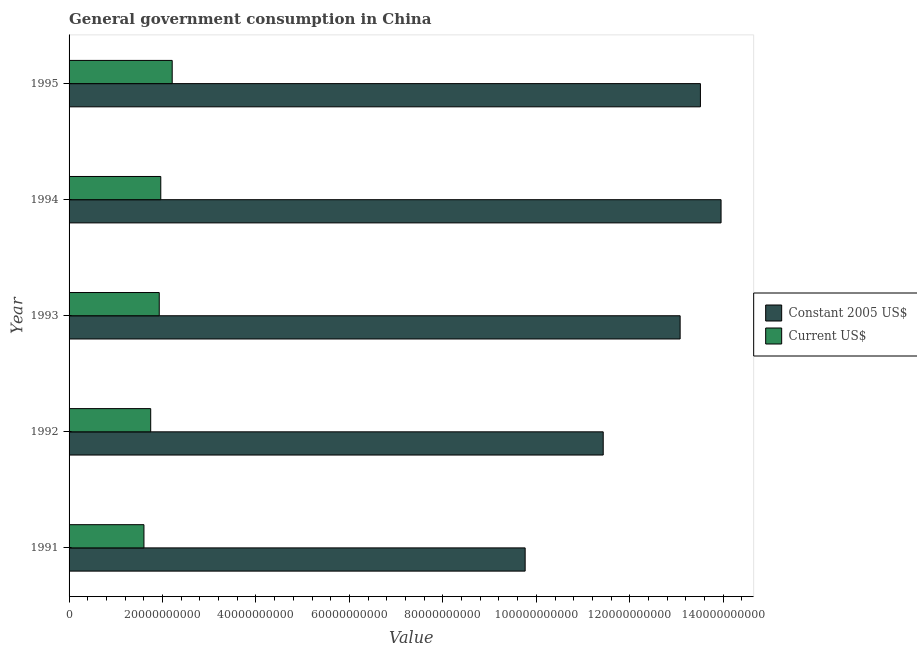How many different coloured bars are there?
Offer a terse response. 2. What is the label of the 3rd group of bars from the top?
Make the answer very short. 1993. What is the value consumed in constant 2005 us$ in 1993?
Your response must be concise. 1.31e+11. Across all years, what is the maximum value consumed in constant 2005 us$?
Ensure brevity in your answer.  1.40e+11. Across all years, what is the minimum value consumed in current us$?
Offer a terse response. 1.60e+1. What is the total value consumed in constant 2005 us$ in the graph?
Give a very brief answer. 6.17e+11. What is the difference between the value consumed in constant 2005 us$ in 1993 and that in 1994?
Offer a very short reply. -8.76e+09. What is the difference between the value consumed in current us$ in 1994 and the value consumed in constant 2005 us$ in 1993?
Offer a very short reply. -1.11e+11. What is the average value consumed in current us$ per year?
Provide a succinct answer. 1.89e+1. In the year 1992, what is the difference between the value consumed in current us$ and value consumed in constant 2005 us$?
Keep it short and to the point. -9.68e+1. In how many years, is the value consumed in constant 2005 us$ greater than 32000000000 ?
Provide a succinct answer. 5. What is the ratio of the value consumed in current us$ in 1994 to that in 1995?
Your response must be concise. 0.89. What is the difference between the highest and the second highest value consumed in constant 2005 us$?
Keep it short and to the point. 4.42e+09. What is the difference between the highest and the lowest value consumed in constant 2005 us$?
Give a very brief answer. 4.19e+1. What does the 2nd bar from the top in 1994 represents?
Make the answer very short. Constant 2005 US$. What does the 1st bar from the bottom in 1994 represents?
Ensure brevity in your answer.  Constant 2005 US$. Are all the bars in the graph horizontal?
Give a very brief answer. Yes. How many years are there in the graph?
Ensure brevity in your answer.  5. What is the difference between two consecutive major ticks on the X-axis?
Provide a succinct answer. 2.00e+1. Does the graph contain any zero values?
Offer a very short reply. No. Does the graph contain grids?
Your answer should be compact. No. Where does the legend appear in the graph?
Offer a very short reply. Center right. How many legend labels are there?
Make the answer very short. 2. What is the title of the graph?
Offer a terse response. General government consumption in China. Does "Non-resident workers" appear as one of the legend labels in the graph?
Keep it short and to the point. No. What is the label or title of the X-axis?
Give a very brief answer. Value. What is the Value of Constant 2005 US$ in 1991?
Your response must be concise. 9.76e+1. What is the Value of Current US$ in 1991?
Make the answer very short. 1.60e+1. What is the Value of Constant 2005 US$ in 1992?
Your answer should be compact. 1.14e+11. What is the Value of Current US$ in 1992?
Ensure brevity in your answer.  1.75e+1. What is the Value of Constant 2005 US$ in 1993?
Your response must be concise. 1.31e+11. What is the Value of Current US$ in 1993?
Provide a succinct answer. 1.93e+1. What is the Value of Constant 2005 US$ in 1994?
Your answer should be very brief. 1.40e+11. What is the Value in Current US$ in 1994?
Make the answer very short. 1.96e+1. What is the Value in Constant 2005 US$ in 1995?
Your response must be concise. 1.35e+11. What is the Value in Current US$ in 1995?
Ensure brevity in your answer.  2.21e+1. Across all years, what is the maximum Value in Constant 2005 US$?
Your answer should be compact. 1.40e+11. Across all years, what is the maximum Value in Current US$?
Your answer should be very brief. 2.21e+1. Across all years, what is the minimum Value of Constant 2005 US$?
Provide a succinct answer. 9.76e+1. Across all years, what is the minimum Value of Current US$?
Offer a very short reply. 1.60e+1. What is the total Value of Constant 2005 US$ in the graph?
Keep it short and to the point. 6.17e+11. What is the total Value of Current US$ in the graph?
Provide a short and direct response. 9.45e+1. What is the difference between the Value of Constant 2005 US$ in 1991 and that in 1992?
Keep it short and to the point. -1.67e+1. What is the difference between the Value in Current US$ in 1991 and that in 1992?
Give a very brief answer. -1.44e+09. What is the difference between the Value in Constant 2005 US$ in 1991 and that in 1993?
Your answer should be very brief. -3.32e+1. What is the difference between the Value in Current US$ in 1991 and that in 1993?
Your answer should be compact. -3.27e+09. What is the difference between the Value in Constant 2005 US$ in 1991 and that in 1994?
Your answer should be very brief. -4.19e+1. What is the difference between the Value in Current US$ in 1991 and that in 1994?
Make the answer very short. -3.60e+09. What is the difference between the Value of Constant 2005 US$ in 1991 and that in 1995?
Your response must be concise. -3.75e+1. What is the difference between the Value of Current US$ in 1991 and that in 1995?
Your answer should be compact. -6.04e+09. What is the difference between the Value of Constant 2005 US$ in 1992 and that in 1993?
Offer a very short reply. -1.65e+1. What is the difference between the Value of Current US$ in 1992 and that in 1993?
Provide a succinct answer. -1.83e+09. What is the difference between the Value in Constant 2005 US$ in 1992 and that in 1994?
Give a very brief answer. -2.52e+1. What is the difference between the Value in Current US$ in 1992 and that in 1994?
Provide a succinct answer. -2.16e+09. What is the difference between the Value of Constant 2005 US$ in 1992 and that in 1995?
Provide a short and direct response. -2.08e+1. What is the difference between the Value of Current US$ in 1992 and that in 1995?
Provide a succinct answer. -4.60e+09. What is the difference between the Value in Constant 2005 US$ in 1993 and that in 1994?
Provide a short and direct response. -8.76e+09. What is the difference between the Value in Current US$ in 1993 and that in 1994?
Offer a terse response. -3.27e+08. What is the difference between the Value in Constant 2005 US$ in 1993 and that in 1995?
Ensure brevity in your answer.  -4.34e+09. What is the difference between the Value in Current US$ in 1993 and that in 1995?
Provide a short and direct response. -2.77e+09. What is the difference between the Value of Constant 2005 US$ in 1994 and that in 1995?
Make the answer very short. 4.42e+09. What is the difference between the Value of Current US$ in 1994 and that in 1995?
Your response must be concise. -2.44e+09. What is the difference between the Value of Constant 2005 US$ in 1991 and the Value of Current US$ in 1992?
Offer a terse response. 8.01e+1. What is the difference between the Value in Constant 2005 US$ in 1991 and the Value in Current US$ in 1993?
Give a very brief answer. 7.83e+1. What is the difference between the Value in Constant 2005 US$ in 1991 and the Value in Current US$ in 1994?
Provide a succinct answer. 7.80e+1. What is the difference between the Value in Constant 2005 US$ in 1991 and the Value in Current US$ in 1995?
Keep it short and to the point. 7.55e+1. What is the difference between the Value of Constant 2005 US$ in 1992 and the Value of Current US$ in 1993?
Provide a short and direct response. 9.50e+1. What is the difference between the Value in Constant 2005 US$ in 1992 and the Value in Current US$ in 1994?
Your answer should be very brief. 9.47e+1. What is the difference between the Value of Constant 2005 US$ in 1992 and the Value of Current US$ in 1995?
Offer a very short reply. 9.22e+1. What is the difference between the Value in Constant 2005 US$ in 1993 and the Value in Current US$ in 1994?
Ensure brevity in your answer.  1.11e+11. What is the difference between the Value of Constant 2005 US$ in 1993 and the Value of Current US$ in 1995?
Make the answer very short. 1.09e+11. What is the difference between the Value of Constant 2005 US$ in 1994 and the Value of Current US$ in 1995?
Make the answer very short. 1.17e+11. What is the average Value of Constant 2005 US$ per year?
Provide a short and direct response. 1.23e+11. What is the average Value of Current US$ per year?
Ensure brevity in your answer.  1.89e+1. In the year 1991, what is the difference between the Value of Constant 2005 US$ and Value of Current US$?
Offer a terse response. 8.16e+1. In the year 1992, what is the difference between the Value of Constant 2005 US$ and Value of Current US$?
Your answer should be very brief. 9.68e+1. In the year 1993, what is the difference between the Value of Constant 2005 US$ and Value of Current US$?
Offer a terse response. 1.11e+11. In the year 1994, what is the difference between the Value of Constant 2005 US$ and Value of Current US$?
Offer a terse response. 1.20e+11. In the year 1995, what is the difference between the Value of Constant 2005 US$ and Value of Current US$?
Your answer should be compact. 1.13e+11. What is the ratio of the Value of Constant 2005 US$ in 1991 to that in 1992?
Your answer should be compact. 0.85. What is the ratio of the Value in Current US$ in 1991 to that in 1992?
Give a very brief answer. 0.92. What is the ratio of the Value in Constant 2005 US$ in 1991 to that in 1993?
Offer a very short reply. 0.75. What is the ratio of the Value of Current US$ in 1991 to that in 1993?
Provide a succinct answer. 0.83. What is the ratio of the Value in Constant 2005 US$ in 1991 to that in 1994?
Keep it short and to the point. 0.7. What is the ratio of the Value in Current US$ in 1991 to that in 1994?
Provide a short and direct response. 0.82. What is the ratio of the Value in Constant 2005 US$ in 1991 to that in 1995?
Ensure brevity in your answer.  0.72. What is the ratio of the Value of Current US$ in 1991 to that in 1995?
Your answer should be very brief. 0.73. What is the ratio of the Value of Constant 2005 US$ in 1992 to that in 1993?
Offer a very short reply. 0.87. What is the ratio of the Value in Current US$ in 1992 to that in 1993?
Make the answer very short. 0.91. What is the ratio of the Value in Constant 2005 US$ in 1992 to that in 1994?
Ensure brevity in your answer.  0.82. What is the ratio of the Value of Current US$ in 1992 to that in 1994?
Your response must be concise. 0.89. What is the ratio of the Value in Constant 2005 US$ in 1992 to that in 1995?
Your response must be concise. 0.85. What is the ratio of the Value in Current US$ in 1992 to that in 1995?
Offer a terse response. 0.79. What is the ratio of the Value in Constant 2005 US$ in 1993 to that in 1994?
Your answer should be compact. 0.94. What is the ratio of the Value in Current US$ in 1993 to that in 1994?
Your response must be concise. 0.98. What is the ratio of the Value in Constant 2005 US$ in 1993 to that in 1995?
Offer a very short reply. 0.97. What is the ratio of the Value of Current US$ in 1993 to that in 1995?
Your answer should be very brief. 0.87. What is the ratio of the Value in Constant 2005 US$ in 1994 to that in 1995?
Make the answer very short. 1.03. What is the ratio of the Value in Current US$ in 1994 to that in 1995?
Your response must be concise. 0.89. What is the difference between the highest and the second highest Value of Constant 2005 US$?
Your answer should be very brief. 4.42e+09. What is the difference between the highest and the second highest Value of Current US$?
Your answer should be very brief. 2.44e+09. What is the difference between the highest and the lowest Value in Constant 2005 US$?
Your answer should be very brief. 4.19e+1. What is the difference between the highest and the lowest Value of Current US$?
Your answer should be very brief. 6.04e+09. 